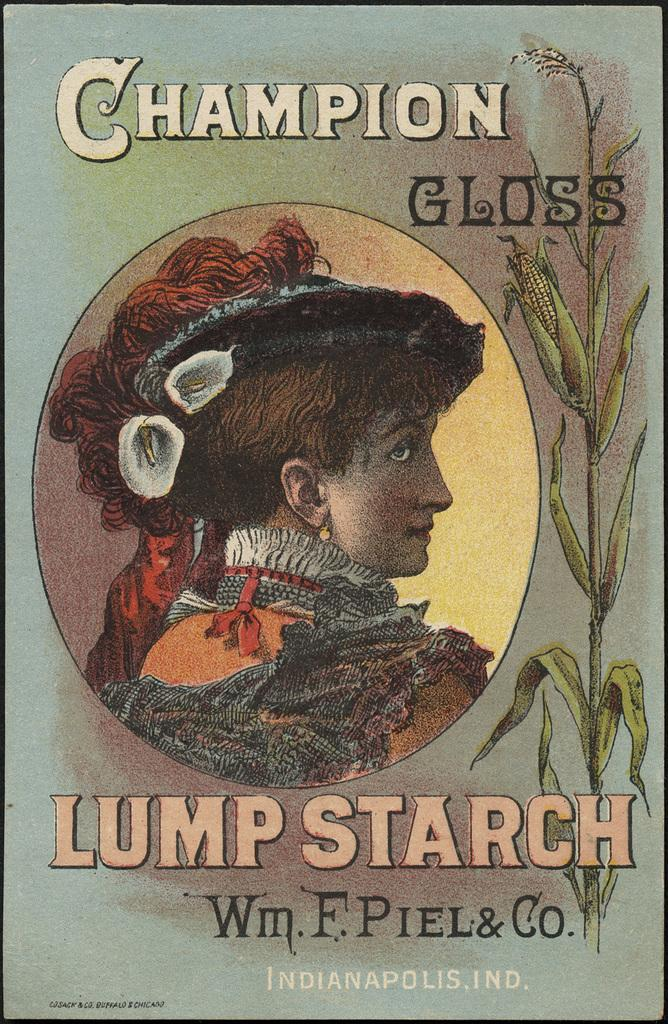Provide a one-sentence caption for the provided image. A box of Champion Gloss lump starch hails from Indianapolis, Indiana. 